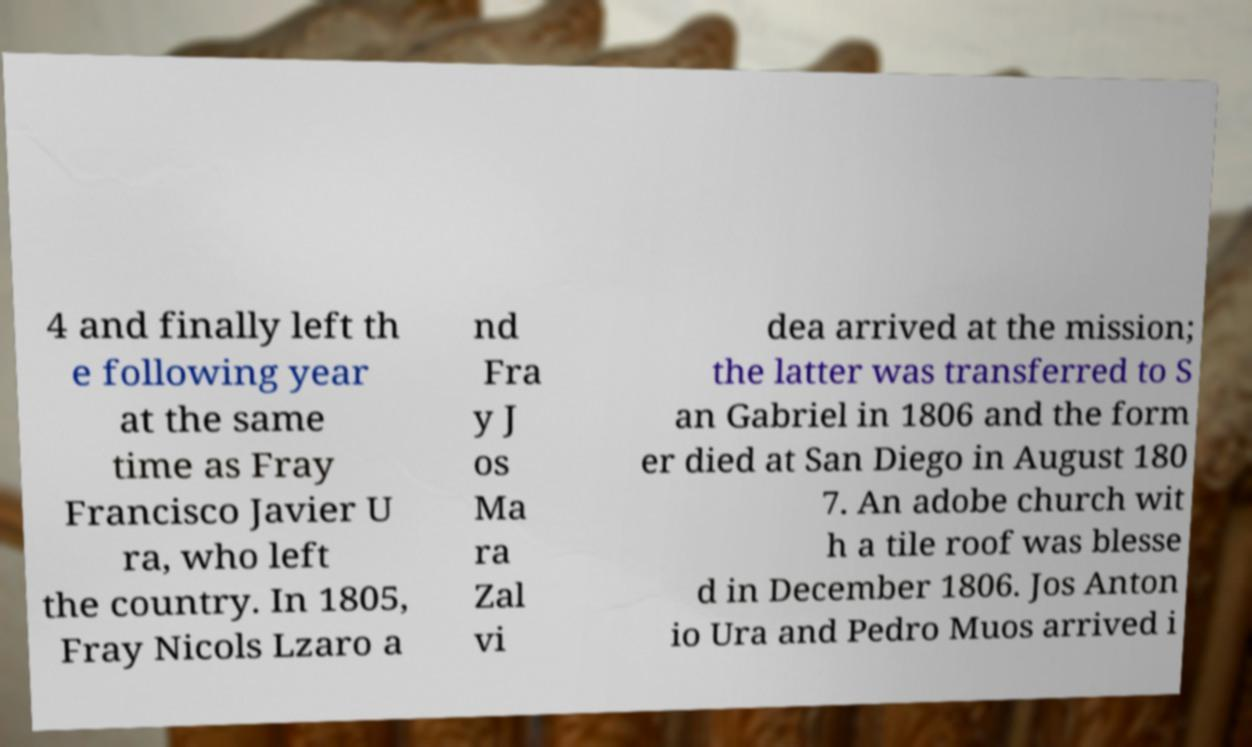Can you accurately transcribe the text from the provided image for me? 4 and finally left th e following year at the same time as Fray Francisco Javier U ra, who left the country. In 1805, Fray Nicols Lzaro a nd Fra y J os Ma ra Zal vi dea arrived at the mission; the latter was transferred to S an Gabriel in 1806 and the form er died at San Diego in August 180 7. An adobe church wit h a tile roof was blesse d in December 1806. Jos Anton io Ura and Pedro Muos arrived i 